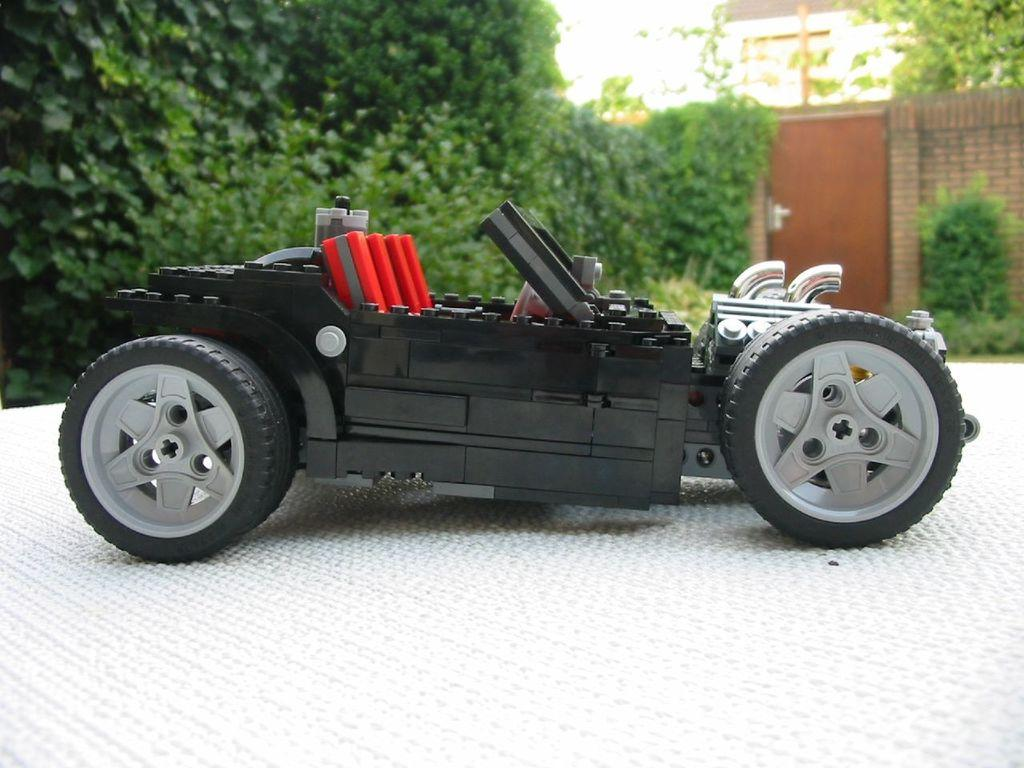What object is placed on the white surface in the image? There is a toy car on a white surface in the image. What type of vegetation can be seen in the image? There are plants and trees in the image. What architectural features are present in the image? There is a door and a wall in the image. What part of the natural environment is visible in the image? The sky is visible in the image. What type of advice is being given by the flag in the image? There is no flag present in the image, so no advice can be given by a flag. Who is delivering the parcel in the image? There is no parcel or person delivering it in the image. 